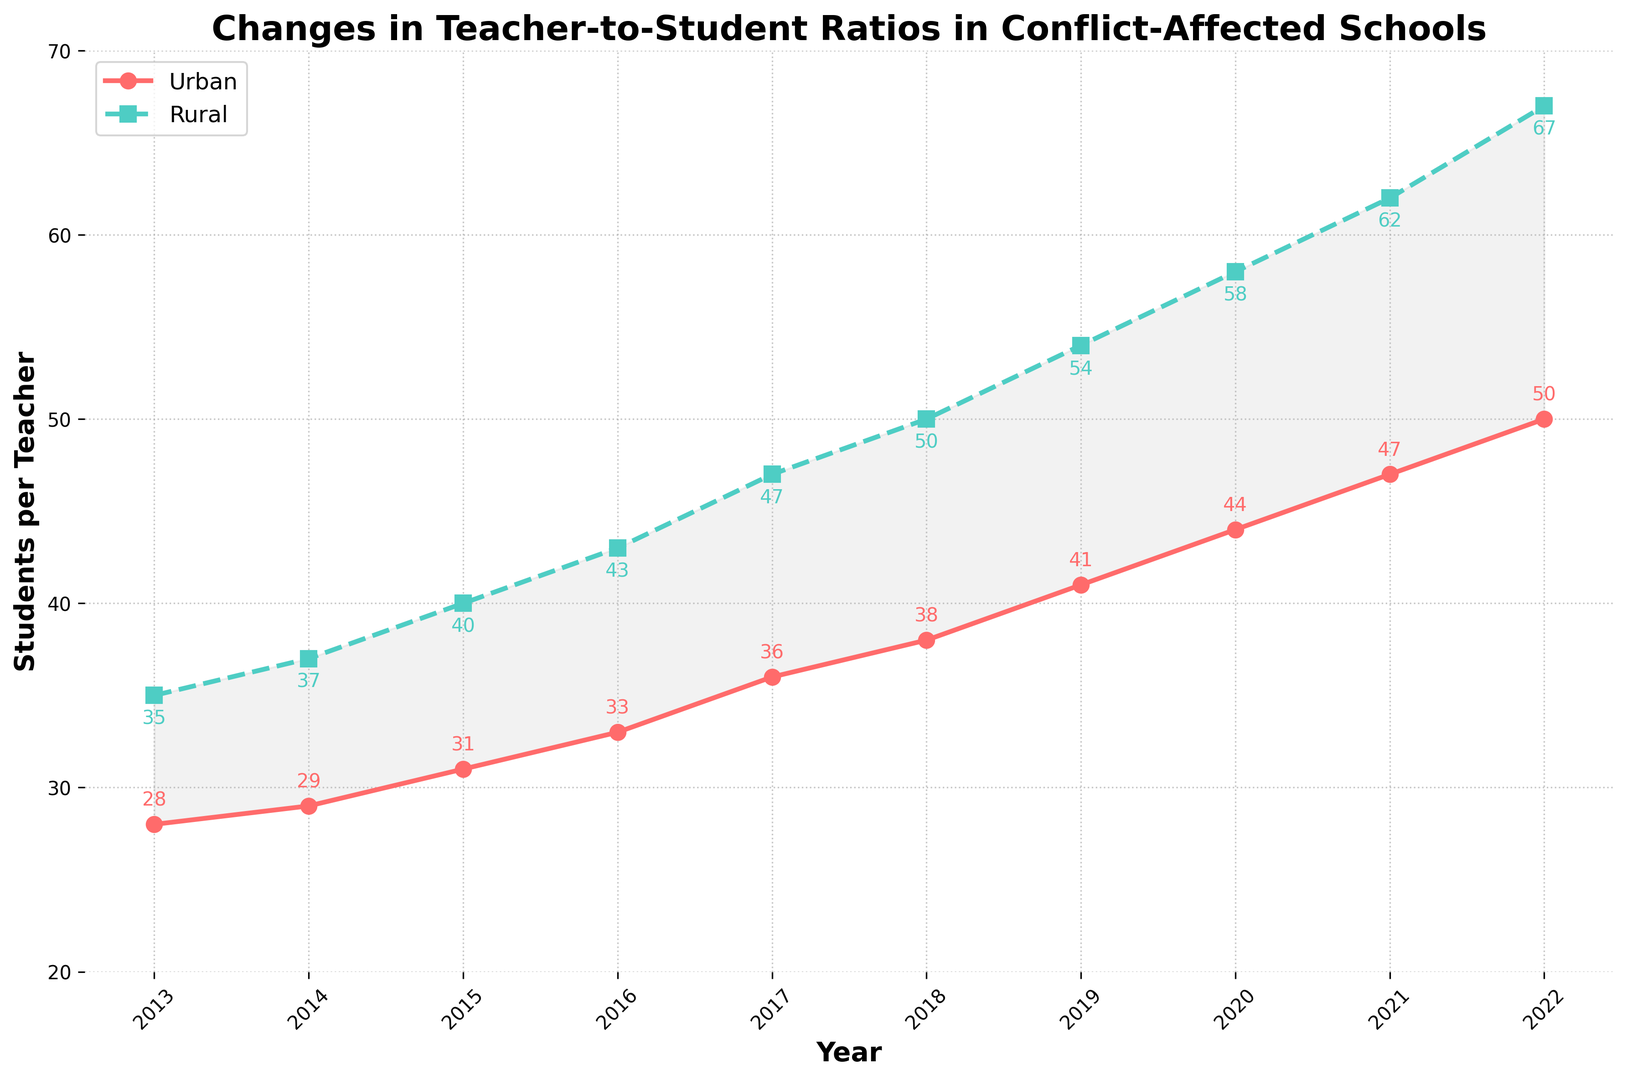Which area had a higher teacher-to-student ratio in 2022? Locate the 2022 data points for both urban and rural areas. Compare the values given: 50 (Urban) and 67 (Rural). Since 67 > 50, rural has a higher ratio.
Answer: Rural How has the teacher-to-student ratio changed in urban areas from 2013 to 2022? Identify the urban teacher-to-student ratio values for 2013 (28) and 2022 (50). Calculate the change by subtracting the 2013 value from the 2022 value: 50 - 28 = 22.
Answer: Increased by 22 What is the difference in teacher-to-student ratios between urban and rural areas in 2020? Look at the data points for 2020: Urban (44) and Rural (58). Subtract the urban value from the rural value: 58 - 44 = 14.
Answer: 14 Which year showed the largest gap between urban and rural teacher-to-student ratios? Calculate the difference between the urban and rural ratios for each year: 
2013: 35-28=7,
2014: 37-29=8,
2015: 40-31=9,
2016: 43-33=10,
2017: 47-36=11,
2018: 50-38=12,
2019: 54-41=13,
2020: 58-44=14,
2021: 62-47=15,
2022: 67-50=17. The largest difference is in 2022.
Answer: 2022 By how much did the rural teacher-to-student ratio increase between 2015 and 2018? Locate the rural ratios for 2015 (40) and 2018 (50). Calculate the increase: 50 - 40 = 10.
Answer: 10 What can be inferred about the trend of teacher-to-student ratios in urban schools from the chart? Review the visual representation of the data points for urban areas. Observe that the ratio increases consistently from 2013 to 2022.
Answer: Consistently increasing What was the average teacher-to-student ratio for rural areas over the past decade? Sum the rural ratios: 35+37+40+43+47+50+54+58+62+67 = 493. Divide by the number of years (10): 493 / 10 = 49.3.
Answer: 49.3 How did the urban and rural teacher-to-student ratios compare in 2017? Locate the data for both urban (36) and rural (47) in 2017. Urban ratio is lower than the rural ratio: 36 < 47.
Answer: Urban ratio is lower 